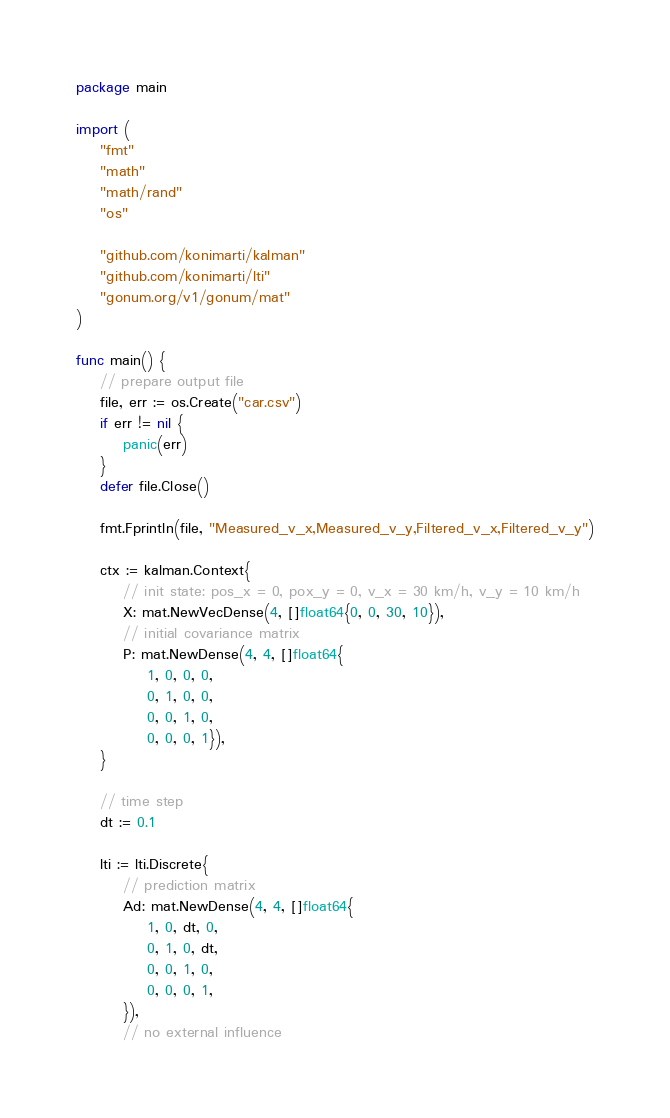Convert code to text. <code><loc_0><loc_0><loc_500><loc_500><_Go_>package main

import (
	"fmt"
	"math"
	"math/rand"
	"os"

	"github.com/konimarti/kalman"
	"github.com/konimarti/lti"
	"gonum.org/v1/gonum/mat"
)

func main() {
	// prepare output file
	file, err := os.Create("car.csv")
	if err != nil {
		panic(err)
	}
	defer file.Close()

	fmt.Fprintln(file, "Measured_v_x,Measured_v_y,Filtered_v_x,Filtered_v_y")

	ctx := kalman.Context{
		// init state: pos_x = 0, pox_y = 0, v_x = 30 km/h, v_y = 10 km/h
		X: mat.NewVecDense(4, []float64{0, 0, 30, 10}),
		// initial covariance matrix
		P: mat.NewDense(4, 4, []float64{
			1, 0, 0, 0,
			0, 1, 0, 0,
			0, 0, 1, 0,
			0, 0, 0, 1}),
	}

	// time step
	dt := 0.1

	lti := lti.Discrete{
		// prediction matrix
		Ad: mat.NewDense(4, 4, []float64{
			1, 0, dt, 0,
			0, 1, 0, dt,
			0, 0, 1, 0,
			0, 0, 0, 1,
		}),
		// no external influence</code> 